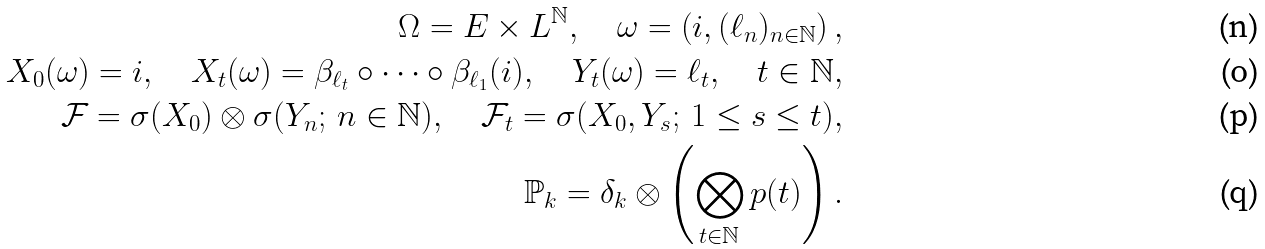<formula> <loc_0><loc_0><loc_500><loc_500>\Omega = E \times L ^ { \mathbb { N } } , \quad \omega = \left ( i , ( \ell _ { n } ) _ { n \in \mathbb { N } } \right ) , \\ X _ { 0 } ( \omega ) = i , \quad X _ { t } ( \omega ) = \beta _ { \ell _ { t } } \circ \cdots \circ \beta _ { \ell _ { 1 } } ( i ) , \quad Y _ { t } ( \omega ) = \ell _ { t } , \quad t \in \mathbb { N } , \\ \mathcal { F } = \sigma ( X _ { 0 } ) \otimes \sigma ( Y _ { n } ; \, n \in \mathbb { N } ) , \quad \mathcal { F } _ { t } = \sigma ( X _ { 0 } , Y _ { s } ; \, 1 \leq s \leq t ) , \\ \mathbb { P } _ { k } = \delta _ { k } \otimes \left ( \bigotimes _ { t \in \mathbb { N } } p ( t ) \right ) .</formula> 